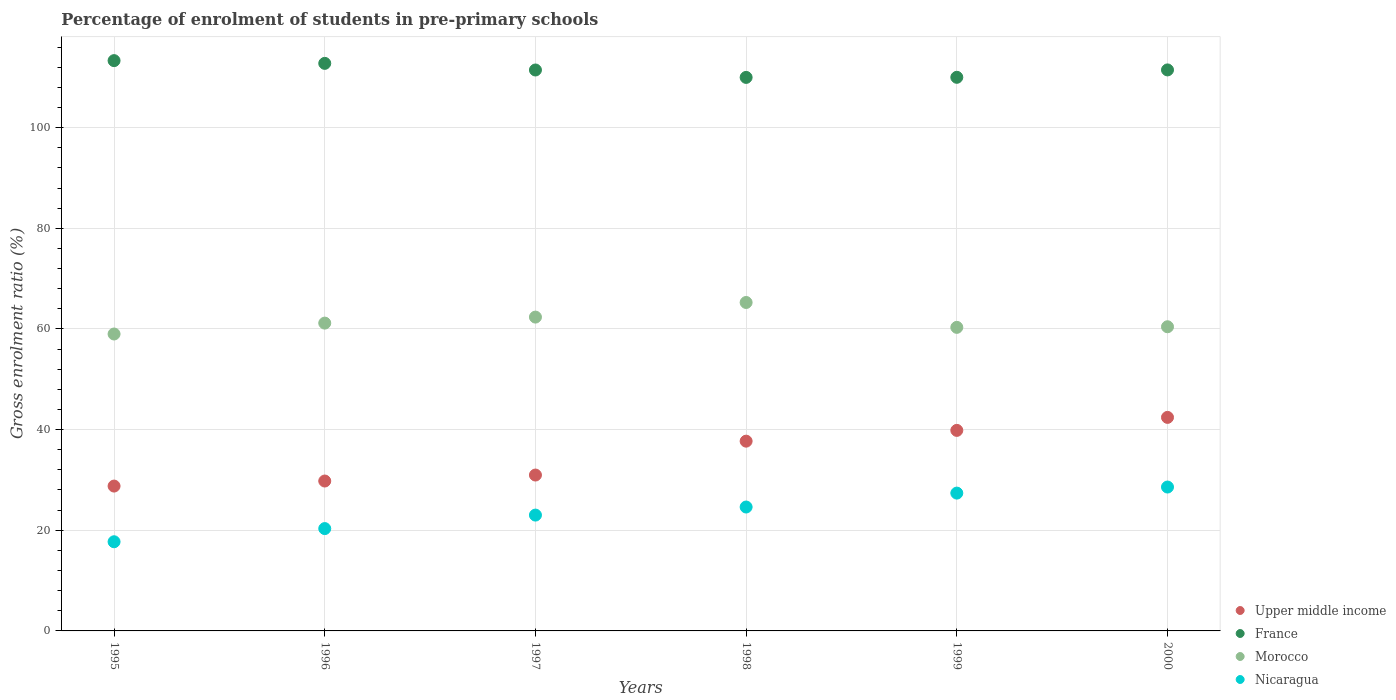Is the number of dotlines equal to the number of legend labels?
Provide a succinct answer. Yes. What is the percentage of students enrolled in pre-primary schools in Nicaragua in 1999?
Offer a terse response. 27.38. Across all years, what is the maximum percentage of students enrolled in pre-primary schools in Upper middle income?
Your answer should be very brief. 42.43. Across all years, what is the minimum percentage of students enrolled in pre-primary schools in France?
Offer a terse response. 109.98. In which year was the percentage of students enrolled in pre-primary schools in Upper middle income maximum?
Provide a succinct answer. 2000. In which year was the percentage of students enrolled in pre-primary schools in Nicaragua minimum?
Offer a terse response. 1995. What is the total percentage of students enrolled in pre-primary schools in Nicaragua in the graph?
Offer a very short reply. 141.65. What is the difference between the percentage of students enrolled in pre-primary schools in Morocco in 1997 and that in 1999?
Ensure brevity in your answer.  2.04. What is the difference between the percentage of students enrolled in pre-primary schools in Nicaragua in 1995 and the percentage of students enrolled in pre-primary schools in Upper middle income in 2000?
Your answer should be very brief. -24.71. What is the average percentage of students enrolled in pre-primary schools in Nicaragua per year?
Give a very brief answer. 23.61. In the year 1999, what is the difference between the percentage of students enrolled in pre-primary schools in Upper middle income and percentage of students enrolled in pre-primary schools in France?
Provide a short and direct response. -70.15. What is the ratio of the percentage of students enrolled in pre-primary schools in Nicaragua in 1998 to that in 2000?
Provide a succinct answer. 0.86. Is the difference between the percentage of students enrolled in pre-primary schools in Upper middle income in 1999 and 2000 greater than the difference between the percentage of students enrolled in pre-primary schools in France in 1999 and 2000?
Provide a succinct answer. No. What is the difference between the highest and the second highest percentage of students enrolled in pre-primary schools in Morocco?
Offer a terse response. 2.9. What is the difference between the highest and the lowest percentage of students enrolled in pre-primary schools in Upper middle income?
Provide a short and direct response. 13.65. Is it the case that in every year, the sum of the percentage of students enrolled in pre-primary schools in France and percentage of students enrolled in pre-primary schools in Nicaragua  is greater than the percentage of students enrolled in pre-primary schools in Morocco?
Make the answer very short. Yes. Does the percentage of students enrolled in pre-primary schools in France monotonically increase over the years?
Provide a succinct answer. No. How many years are there in the graph?
Your answer should be very brief. 6. Are the values on the major ticks of Y-axis written in scientific E-notation?
Provide a short and direct response. No. What is the title of the graph?
Your answer should be very brief. Percentage of enrolment of students in pre-primary schools. What is the label or title of the X-axis?
Provide a succinct answer. Years. What is the Gross enrolment ratio (%) in Upper middle income in 1995?
Provide a succinct answer. 28.78. What is the Gross enrolment ratio (%) of France in 1995?
Make the answer very short. 113.31. What is the Gross enrolment ratio (%) of Morocco in 1995?
Give a very brief answer. 58.99. What is the Gross enrolment ratio (%) in Nicaragua in 1995?
Ensure brevity in your answer.  17.72. What is the Gross enrolment ratio (%) in Upper middle income in 1996?
Keep it short and to the point. 29.78. What is the Gross enrolment ratio (%) of France in 1996?
Your response must be concise. 112.77. What is the Gross enrolment ratio (%) in Morocco in 1996?
Your response must be concise. 61.16. What is the Gross enrolment ratio (%) in Nicaragua in 1996?
Ensure brevity in your answer.  20.33. What is the Gross enrolment ratio (%) of Upper middle income in 1997?
Keep it short and to the point. 30.97. What is the Gross enrolment ratio (%) of France in 1997?
Offer a very short reply. 111.45. What is the Gross enrolment ratio (%) in Morocco in 1997?
Keep it short and to the point. 62.35. What is the Gross enrolment ratio (%) in Nicaragua in 1997?
Your answer should be very brief. 23.01. What is the Gross enrolment ratio (%) in Upper middle income in 1998?
Keep it short and to the point. 37.7. What is the Gross enrolment ratio (%) in France in 1998?
Your answer should be very brief. 109.98. What is the Gross enrolment ratio (%) of Morocco in 1998?
Provide a short and direct response. 65.26. What is the Gross enrolment ratio (%) of Nicaragua in 1998?
Make the answer very short. 24.62. What is the Gross enrolment ratio (%) in Upper middle income in 1999?
Offer a very short reply. 39.85. What is the Gross enrolment ratio (%) of France in 1999?
Provide a succinct answer. 110. What is the Gross enrolment ratio (%) in Morocco in 1999?
Offer a very short reply. 60.31. What is the Gross enrolment ratio (%) of Nicaragua in 1999?
Keep it short and to the point. 27.38. What is the Gross enrolment ratio (%) of Upper middle income in 2000?
Keep it short and to the point. 42.43. What is the Gross enrolment ratio (%) of France in 2000?
Your answer should be compact. 111.47. What is the Gross enrolment ratio (%) of Morocco in 2000?
Keep it short and to the point. 60.43. What is the Gross enrolment ratio (%) of Nicaragua in 2000?
Offer a very short reply. 28.59. Across all years, what is the maximum Gross enrolment ratio (%) in Upper middle income?
Your response must be concise. 42.43. Across all years, what is the maximum Gross enrolment ratio (%) of France?
Your answer should be very brief. 113.31. Across all years, what is the maximum Gross enrolment ratio (%) of Morocco?
Your answer should be very brief. 65.26. Across all years, what is the maximum Gross enrolment ratio (%) in Nicaragua?
Your response must be concise. 28.59. Across all years, what is the minimum Gross enrolment ratio (%) of Upper middle income?
Provide a succinct answer. 28.78. Across all years, what is the minimum Gross enrolment ratio (%) of France?
Your response must be concise. 109.98. Across all years, what is the minimum Gross enrolment ratio (%) in Morocco?
Keep it short and to the point. 58.99. Across all years, what is the minimum Gross enrolment ratio (%) of Nicaragua?
Your answer should be compact. 17.72. What is the total Gross enrolment ratio (%) of Upper middle income in the graph?
Offer a terse response. 209.51. What is the total Gross enrolment ratio (%) in France in the graph?
Provide a succinct answer. 668.97. What is the total Gross enrolment ratio (%) of Morocco in the graph?
Make the answer very short. 368.51. What is the total Gross enrolment ratio (%) of Nicaragua in the graph?
Make the answer very short. 141.65. What is the difference between the Gross enrolment ratio (%) in Upper middle income in 1995 and that in 1996?
Offer a very short reply. -1. What is the difference between the Gross enrolment ratio (%) in France in 1995 and that in 1996?
Your response must be concise. 0.54. What is the difference between the Gross enrolment ratio (%) in Morocco in 1995 and that in 1996?
Give a very brief answer. -2.16. What is the difference between the Gross enrolment ratio (%) in Nicaragua in 1995 and that in 1996?
Your answer should be compact. -2.62. What is the difference between the Gross enrolment ratio (%) in Upper middle income in 1995 and that in 1997?
Keep it short and to the point. -2.19. What is the difference between the Gross enrolment ratio (%) of France in 1995 and that in 1997?
Your answer should be very brief. 1.86. What is the difference between the Gross enrolment ratio (%) of Morocco in 1995 and that in 1997?
Make the answer very short. -3.36. What is the difference between the Gross enrolment ratio (%) of Nicaragua in 1995 and that in 1997?
Your answer should be very brief. -5.3. What is the difference between the Gross enrolment ratio (%) of Upper middle income in 1995 and that in 1998?
Your answer should be compact. -8.92. What is the difference between the Gross enrolment ratio (%) in France in 1995 and that in 1998?
Ensure brevity in your answer.  3.33. What is the difference between the Gross enrolment ratio (%) in Morocco in 1995 and that in 1998?
Offer a very short reply. -6.26. What is the difference between the Gross enrolment ratio (%) of Nicaragua in 1995 and that in 1998?
Provide a succinct answer. -6.9. What is the difference between the Gross enrolment ratio (%) in Upper middle income in 1995 and that in 1999?
Your answer should be very brief. -11.06. What is the difference between the Gross enrolment ratio (%) in France in 1995 and that in 1999?
Give a very brief answer. 3.31. What is the difference between the Gross enrolment ratio (%) in Morocco in 1995 and that in 1999?
Provide a short and direct response. -1.32. What is the difference between the Gross enrolment ratio (%) in Nicaragua in 1995 and that in 1999?
Make the answer very short. -9.67. What is the difference between the Gross enrolment ratio (%) in Upper middle income in 1995 and that in 2000?
Offer a terse response. -13.65. What is the difference between the Gross enrolment ratio (%) in France in 1995 and that in 2000?
Offer a very short reply. 1.84. What is the difference between the Gross enrolment ratio (%) in Morocco in 1995 and that in 2000?
Your response must be concise. -1.44. What is the difference between the Gross enrolment ratio (%) in Nicaragua in 1995 and that in 2000?
Offer a terse response. -10.87. What is the difference between the Gross enrolment ratio (%) in Upper middle income in 1996 and that in 1997?
Give a very brief answer. -1.19. What is the difference between the Gross enrolment ratio (%) of France in 1996 and that in 1997?
Your answer should be compact. 1.32. What is the difference between the Gross enrolment ratio (%) in Morocco in 1996 and that in 1997?
Offer a very short reply. -1.19. What is the difference between the Gross enrolment ratio (%) in Nicaragua in 1996 and that in 1997?
Make the answer very short. -2.68. What is the difference between the Gross enrolment ratio (%) of Upper middle income in 1996 and that in 1998?
Your answer should be very brief. -7.92. What is the difference between the Gross enrolment ratio (%) of France in 1996 and that in 1998?
Your answer should be compact. 2.79. What is the difference between the Gross enrolment ratio (%) of Morocco in 1996 and that in 1998?
Offer a terse response. -4.1. What is the difference between the Gross enrolment ratio (%) of Nicaragua in 1996 and that in 1998?
Your response must be concise. -4.28. What is the difference between the Gross enrolment ratio (%) of Upper middle income in 1996 and that in 1999?
Your answer should be very brief. -10.06. What is the difference between the Gross enrolment ratio (%) of France in 1996 and that in 1999?
Provide a short and direct response. 2.77. What is the difference between the Gross enrolment ratio (%) in Morocco in 1996 and that in 1999?
Ensure brevity in your answer.  0.84. What is the difference between the Gross enrolment ratio (%) of Nicaragua in 1996 and that in 1999?
Make the answer very short. -7.05. What is the difference between the Gross enrolment ratio (%) in Upper middle income in 1996 and that in 2000?
Offer a very short reply. -12.64. What is the difference between the Gross enrolment ratio (%) of France in 1996 and that in 2000?
Offer a very short reply. 1.3. What is the difference between the Gross enrolment ratio (%) of Morocco in 1996 and that in 2000?
Offer a very short reply. 0.73. What is the difference between the Gross enrolment ratio (%) of Nicaragua in 1996 and that in 2000?
Your answer should be very brief. -8.25. What is the difference between the Gross enrolment ratio (%) in Upper middle income in 1997 and that in 1998?
Your answer should be compact. -6.73. What is the difference between the Gross enrolment ratio (%) of France in 1997 and that in 1998?
Your response must be concise. 1.47. What is the difference between the Gross enrolment ratio (%) of Morocco in 1997 and that in 1998?
Offer a very short reply. -2.9. What is the difference between the Gross enrolment ratio (%) of Nicaragua in 1997 and that in 1998?
Your response must be concise. -1.6. What is the difference between the Gross enrolment ratio (%) in Upper middle income in 1997 and that in 1999?
Keep it short and to the point. -8.87. What is the difference between the Gross enrolment ratio (%) of France in 1997 and that in 1999?
Your answer should be compact. 1.45. What is the difference between the Gross enrolment ratio (%) of Morocco in 1997 and that in 1999?
Your answer should be compact. 2.04. What is the difference between the Gross enrolment ratio (%) in Nicaragua in 1997 and that in 1999?
Provide a succinct answer. -4.37. What is the difference between the Gross enrolment ratio (%) in Upper middle income in 1997 and that in 2000?
Make the answer very short. -11.46. What is the difference between the Gross enrolment ratio (%) of France in 1997 and that in 2000?
Make the answer very short. -0.02. What is the difference between the Gross enrolment ratio (%) in Morocco in 1997 and that in 2000?
Ensure brevity in your answer.  1.92. What is the difference between the Gross enrolment ratio (%) in Nicaragua in 1997 and that in 2000?
Offer a terse response. -5.57. What is the difference between the Gross enrolment ratio (%) in Upper middle income in 1998 and that in 1999?
Offer a very short reply. -2.14. What is the difference between the Gross enrolment ratio (%) of France in 1998 and that in 1999?
Ensure brevity in your answer.  -0.02. What is the difference between the Gross enrolment ratio (%) of Morocco in 1998 and that in 1999?
Ensure brevity in your answer.  4.94. What is the difference between the Gross enrolment ratio (%) of Nicaragua in 1998 and that in 1999?
Provide a short and direct response. -2.77. What is the difference between the Gross enrolment ratio (%) in Upper middle income in 1998 and that in 2000?
Your answer should be compact. -4.72. What is the difference between the Gross enrolment ratio (%) of France in 1998 and that in 2000?
Give a very brief answer. -1.49. What is the difference between the Gross enrolment ratio (%) in Morocco in 1998 and that in 2000?
Offer a very short reply. 4.82. What is the difference between the Gross enrolment ratio (%) of Nicaragua in 1998 and that in 2000?
Your answer should be compact. -3.97. What is the difference between the Gross enrolment ratio (%) in Upper middle income in 1999 and that in 2000?
Offer a very short reply. -2.58. What is the difference between the Gross enrolment ratio (%) in France in 1999 and that in 2000?
Provide a succinct answer. -1.47. What is the difference between the Gross enrolment ratio (%) in Morocco in 1999 and that in 2000?
Your answer should be compact. -0.12. What is the difference between the Gross enrolment ratio (%) of Nicaragua in 1999 and that in 2000?
Your response must be concise. -1.2. What is the difference between the Gross enrolment ratio (%) in Upper middle income in 1995 and the Gross enrolment ratio (%) in France in 1996?
Your answer should be compact. -83.99. What is the difference between the Gross enrolment ratio (%) in Upper middle income in 1995 and the Gross enrolment ratio (%) in Morocco in 1996?
Offer a terse response. -32.38. What is the difference between the Gross enrolment ratio (%) of Upper middle income in 1995 and the Gross enrolment ratio (%) of Nicaragua in 1996?
Your answer should be very brief. 8.45. What is the difference between the Gross enrolment ratio (%) of France in 1995 and the Gross enrolment ratio (%) of Morocco in 1996?
Give a very brief answer. 52.15. What is the difference between the Gross enrolment ratio (%) of France in 1995 and the Gross enrolment ratio (%) of Nicaragua in 1996?
Your answer should be very brief. 92.98. What is the difference between the Gross enrolment ratio (%) of Morocco in 1995 and the Gross enrolment ratio (%) of Nicaragua in 1996?
Your answer should be very brief. 38.66. What is the difference between the Gross enrolment ratio (%) of Upper middle income in 1995 and the Gross enrolment ratio (%) of France in 1997?
Make the answer very short. -82.67. What is the difference between the Gross enrolment ratio (%) in Upper middle income in 1995 and the Gross enrolment ratio (%) in Morocco in 1997?
Offer a terse response. -33.57. What is the difference between the Gross enrolment ratio (%) of Upper middle income in 1995 and the Gross enrolment ratio (%) of Nicaragua in 1997?
Your answer should be compact. 5.77. What is the difference between the Gross enrolment ratio (%) in France in 1995 and the Gross enrolment ratio (%) in Morocco in 1997?
Offer a terse response. 50.96. What is the difference between the Gross enrolment ratio (%) of France in 1995 and the Gross enrolment ratio (%) of Nicaragua in 1997?
Your answer should be compact. 90.3. What is the difference between the Gross enrolment ratio (%) in Morocco in 1995 and the Gross enrolment ratio (%) in Nicaragua in 1997?
Make the answer very short. 35.98. What is the difference between the Gross enrolment ratio (%) of Upper middle income in 1995 and the Gross enrolment ratio (%) of France in 1998?
Your answer should be compact. -81.2. What is the difference between the Gross enrolment ratio (%) in Upper middle income in 1995 and the Gross enrolment ratio (%) in Morocco in 1998?
Keep it short and to the point. -36.48. What is the difference between the Gross enrolment ratio (%) in Upper middle income in 1995 and the Gross enrolment ratio (%) in Nicaragua in 1998?
Ensure brevity in your answer.  4.16. What is the difference between the Gross enrolment ratio (%) of France in 1995 and the Gross enrolment ratio (%) of Morocco in 1998?
Give a very brief answer. 48.05. What is the difference between the Gross enrolment ratio (%) in France in 1995 and the Gross enrolment ratio (%) in Nicaragua in 1998?
Your answer should be very brief. 88.69. What is the difference between the Gross enrolment ratio (%) in Morocco in 1995 and the Gross enrolment ratio (%) in Nicaragua in 1998?
Provide a short and direct response. 34.38. What is the difference between the Gross enrolment ratio (%) of Upper middle income in 1995 and the Gross enrolment ratio (%) of France in 1999?
Keep it short and to the point. -81.22. What is the difference between the Gross enrolment ratio (%) in Upper middle income in 1995 and the Gross enrolment ratio (%) in Morocco in 1999?
Give a very brief answer. -31.53. What is the difference between the Gross enrolment ratio (%) of Upper middle income in 1995 and the Gross enrolment ratio (%) of Nicaragua in 1999?
Your answer should be very brief. 1.4. What is the difference between the Gross enrolment ratio (%) in France in 1995 and the Gross enrolment ratio (%) in Morocco in 1999?
Provide a succinct answer. 53. What is the difference between the Gross enrolment ratio (%) of France in 1995 and the Gross enrolment ratio (%) of Nicaragua in 1999?
Your answer should be very brief. 85.93. What is the difference between the Gross enrolment ratio (%) in Morocco in 1995 and the Gross enrolment ratio (%) in Nicaragua in 1999?
Your answer should be compact. 31.61. What is the difference between the Gross enrolment ratio (%) in Upper middle income in 1995 and the Gross enrolment ratio (%) in France in 2000?
Ensure brevity in your answer.  -82.69. What is the difference between the Gross enrolment ratio (%) of Upper middle income in 1995 and the Gross enrolment ratio (%) of Morocco in 2000?
Your answer should be compact. -31.65. What is the difference between the Gross enrolment ratio (%) of Upper middle income in 1995 and the Gross enrolment ratio (%) of Nicaragua in 2000?
Offer a very short reply. 0.19. What is the difference between the Gross enrolment ratio (%) in France in 1995 and the Gross enrolment ratio (%) in Morocco in 2000?
Provide a succinct answer. 52.88. What is the difference between the Gross enrolment ratio (%) in France in 1995 and the Gross enrolment ratio (%) in Nicaragua in 2000?
Ensure brevity in your answer.  84.72. What is the difference between the Gross enrolment ratio (%) in Morocco in 1995 and the Gross enrolment ratio (%) in Nicaragua in 2000?
Your answer should be compact. 30.41. What is the difference between the Gross enrolment ratio (%) in Upper middle income in 1996 and the Gross enrolment ratio (%) in France in 1997?
Your answer should be compact. -81.67. What is the difference between the Gross enrolment ratio (%) of Upper middle income in 1996 and the Gross enrolment ratio (%) of Morocco in 1997?
Keep it short and to the point. -32.57. What is the difference between the Gross enrolment ratio (%) in Upper middle income in 1996 and the Gross enrolment ratio (%) in Nicaragua in 1997?
Keep it short and to the point. 6.77. What is the difference between the Gross enrolment ratio (%) of France in 1996 and the Gross enrolment ratio (%) of Morocco in 1997?
Offer a very short reply. 50.41. What is the difference between the Gross enrolment ratio (%) in France in 1996 and the Gross enrolment ratio (%) in Nicaragua in 1997?
Keep it short and to the point. 89.75. What is the difference between the Gross enrolment ratio (%) of Morocco in 1996 and the Gross enrolment ratio (%) of Nicaragua in 1997?
Offer a terse response. 38.14. What is the difference between the Gross enrolment ratio (%) of Upper middle income in 1996 and the Gross enrolment ratio (%) of France in 1998?
Ensure brevity in your answer.  -80.19. What is the difference between the Gross enrolment ratio (%) in Upper middle income in 1996 and the Gross enrolment ratio (%) in Morocco in 1998?
Your answer should be compact. -35.47. What is the difference between the Gross enrolment ratio (%) in Upper middle income in 1996 and the Gross enrolment ratio (%) in Nicaragua in 1998?
Provide a short and direct response. 5.17. What is the difference between the Gross enrolment ratio (%) of France in 1996 and the Gross enrolment ratio (%) of Morocco in 1998?
Give a very brief answer. 47.51. What is the difference between the Gross enrolment ratio (%) in France in 1996 and the Gross enrolment ratio (%) in Nicaragua in 1998?
Your response must be concise. 88.15. What is the difference between the Gross enrolment ratio (%) of Morocco in 1996 and the Gross enrolment ratio (%) of Nicaragua in 1998?
Your response must be concise. 36.54. What is the difference between the Gross enrolment ratio (%) of Upper middle income in 1996 and the Gross enrolment ratio (%) of France in 1999?
Your response must be concise. -80.21. What is the difference between the Gross enrolment ratio (%) of Upper middle income in 1996 and the Gross enrolment ratio (%) of Morocco in 1999?
Offer a terse response. -30.53. What is the difference between the Gross enrolment ratio (%) in Upper middle income in 1996 and the Gross enrolment ratio (%) in Nicaragua in 1999?
Your answer should be very brief. 2.4. What is the difference between the Gross enrolment ratio (%) in France in 1996 and the Gross enrolment ratio (%) in Morocco in 1999?
Your response must be concise. 52.45. What is the difference between the Gross enrolment ratio (%) in France in 1996 and the Gross enrolment ratio (%) in Nicaragua in 1999?
Your response must be concise. 85.38. What is the difference between the Gross enrolment ratio (%) in Morocco in 1996 and the Gross enrolment ratio (%) in Nicaragua in 1999?
Offer a terse response. 33.78. What is the difference between the Gross enrolment ratio (%) in Upper middle income in 1996 and the Gross enrolment ratio (%) in France in 2000?
Offer a terse response. -81.68. What is the difference between the Gross enrolment ratio (%) in Upper middle income in 1996 and the Gross enrolment ratio (%) in Morocco in 2000?
Your answer should be very brief. -30.65. What is the difference between the Gross enrolment ratio (%) in Upper middle income in 1996 and the Gross enrolment ratio (%) in Nicaragua in 2000?
Your answer should be compact. 1.2. What is the difference between the Gross enrolment ratio (%) in France in 1996 and the Gross enrolment ratio (%) in Morocco in 2000?
Your answer should be compact. 52.33. What is the difference between the Gross enrolment ratio (%) in France in 1996 and the Gross enrolment ratio (%) in Nicaragua in 2000?
Your answer should be very brief. 84.18. What is the difference between the Gross enrolment ratio (%) in Morocco in 1996 and the Gross enrolment ratio (%) in Nicaragua in 2000?
Make the answer very short. 32.57. What is the difference between the Gross enrolment ratio (%) in Upper middle income in 1997 and the Gross enrolment ratio (%) in France in 1998?
Give a very brief answer. -79.01. What is the difference between the Gross enrolment ratio (%) in Upper middle income in 1997 and the Gross enrolment ratio (%) in Morocco in 1998?
Offer a very short reply. -34.29. What is the difference between the Gross enrolment ratio (%) in Upper middle income in 1997 and the Gross enrolment ratio (%) in Nicaragua in 1998?
Your answer should be compact. 6.35. What is the difference between the Gross enrolment ratio (%) in France in 1997 and the Gross enrolment ratio (%) in Morocco in 1998?
Provide a succinct answer. 46.19. What is the difference between the Gross enrolment ratio (%) of France in 1997 and the Gross enrolment ratio (%) of Nicaragua in 1998?
Keep it short and to the point. 86.83. What is the difference between the Gross enrolment ratio (%) in Morocco in 1997 and the Gross enrolment ratio (%) in Nicaragua in 1998?
Offer a terse response. 37.74. What is the difference between the Gross enrolment ratio (%) in Upper middle income in 1997 and the Gross enrolment ratio (%) in France in 1999?
Keep it short and to the point. -79.03. What is the difference between the Gross enrolment ratio (%) in Upper middle income in 1997 and the Gross enrolment ratio (%) in Morocco in 1999?
Make the answer very short. -29.34. What is the difference between the Gross enrolment ratio (%) of Upper middle income in 1997 and the Gross enrolment ratio (%) of Nicaragua in 1999?
Offer a terse response. 3.59. What is the difference between the Gross enrolment ratio (%) of France in 1997 and the Gross enrolment ratio (%) of Morocco in 1999?
Keep it short and to the point. 51.14. What is the difference between the Gross enrolment ratio (%) of France in 1997 and the Gross enrolment ratio (%) of Nicaragua in 1999?
Provide a succinct answer. 84.07. What is the difference between the Gross enrolment ratio (%) in Morocco in 1997 and the Gross enrolment ratio (%) in Nicaragua in 1999?
Offer a terse response. 34.97. What is the difference between the Gross enrolment ratio (%) in Upper middle income in 1997 and the Gross enrolment ratio (%) in France in 2000?
Give a very brief answer. -80.49. What is the difference between the Gross enrolment ratio (%) of Upper middle income in 1997 and the Gross enrolment ratio (%) of Morocco in 2000?
Offer a terse response. -29.46. What is the difference between the Gross enrolment ratio (%) of Upper middle income in 1997 and the Gross enrolment ratio (%) of Nicaragua in 2000?
Your answer should be compact. 2.38. What is the difference between the Gross enrolment ratio (%) of France in 1997 and the Gross enrolment ratio (%) of Morocco in 2000?
Provide a succinct answer. 51.02. What is the difference between the Gross enrolment ratio (%) of France in 1997 and the Gross enrolment ratio (%) of Nicaragua in 2000?
Your answer should be very brief. 82.86. What is the difference between the Gross enrolment ratio (%) of Morocco in 1997 and the Gross enrolment ratio (%) of Nicaragua in 2000?
Your response must be concise. 33.77. What is the difference between the Gross enrolment ratio (%) in Upper middle income in 1998 and the Gross enrolment ratio (%) in France in 1999?
Make the answer very short. -72.29. What is the difference between the Gross enrolment ratio (%) of Upper middle income in 1998 and the Gross enrolment ratio (%) of Morocco in 1999?
Your response must be concise. -22.61. What is the difference between the Gross enrolment ratio (%) of Upper middle income in 1998 and the Gross enrolment ratio (%) of Nicaragua in 1999?
Provide a succinct answer. 10.32. What is the difference between the Gross enrolment ratio (%) of France in 1998 and the Gross enrolment ratio (%) of Morocco in 1999?
Keep it short and to the point. 49.66. What is the difference between the Gross enrolment ratio (%) in France in 1998 and the Gross enrolment ratio (%) in Nicaragua in 1999?
Offer a very short reply. 82.6. What is the difference between the Gross enrolment ratio (%) of Morocco in 1998 and the Gross enrolment ratio (%) of Nicaragua in 1999?
Keep it short and to the point. 37.87. What is the difference between the Gross enrolment ratio (%) in Upper middle income in 1998 and the Gross enrolment ratio (%) in France in 2000?
Ensure brevity in your answer.  -73.76. What is the difference between the Gross enrolment ratio (%) in Upper middle income in 1998 and the Gross enrolment ratio (%) in Morocco in 2000?
Give a very brief answer. -22.73. What is the difference between the Gross enrolment ratio (%) in Upper middle income in 1998 and the Gross enrolment ratio (%) in Nicaragua in 2000?
Provide a short and direct response. 9.12. What is the difference between the Gross enrolment ratio (%) in France in 1998 and the Gross enrolment ratio (%) in Morocco in 2000?
Give a very brief answer. 49.54. What is the difference between the Gross enrolment ratio (%) in France in 1998 and the Gross enrolment ratio (%) in Nicaragua in 2000?
Keep it short and to the point. 81.39. What is the difference between the Gross enrolment ratio (%) in Morocco in 1998 and the Gross enrolment ratio (%) in Nicaragua in 2000?
Offer a terse response. 36.67. What is the difference between the Gross enrolment ratio (%) in Upper middle income in 1999 and the Gross enrolment ratio (%) in France in 2000?
Give a very brief answer. -71.62. What is the difference between the Gross enrolment ratio (%) of Upper middle income in 1999 and the Gross enrolment ratio (%) of Morocco in 2000?
Your answer should be very brief. -20.59. What is the difference between the Gross enrolment ratio (%) in Upper middle income in 1999 and the Gross enrolment ratio (%) in Nicaragua in 2000?
Keep it short and to the point. 11.26. What is the difference between the Gross enrolment ratio (%) of France in 1999 and the Gross enrolment ratio (%) of Morocco in 2000?
Provide a short and direct response. 49.56. What is the difference between the Gross enrolment ratio (%) in France in 1999 and the Gross enrolment ratio (%) in Nicaragua in 2000?
Offer a terse response. 81.41. What is the difference between the Gross enrolment ratio (%) in Morocco in 1999 and the Gross enrolment ratio (%) in Nicaragua in 2000?
Ensure brevity in your answer.  31.73. What is the average Gross enrolment ratio (%) of Upper middle income per year?
Offer a very short reply. 34.92. What is the average Gross enrolment ratio (%) of France per year?
Make the answer very short. 111.49. What is the average Gross enrolment ratio (%) of Morocco per year?
Provide a succinct answer. 61.42. What is the average Gross enrolment ratio (%) of Nicaragua per year?
Provide a short and direct response. 23.61. In the year 1995, what is the difference between the Gross enrolment ratio (%) of Upper middle income and Gross enrolment ratio (%) of France?
Your answer should be very brief. -84.53. In the year 1995, what is the difference between the Gross enrolment ratio (%) of Upper middle income and Gross enrolment ratio (%) of Morocco?
Your answer should be compact. -30.21. In the year 1995, what is the difference between the Gross enrolment ratio (%) in Upper middle income and Gross enrolment ratio (%) in Nicaragua?
Provide a short and direct response. 11.06. In the year 1995, what is the difference between the Gross enrolment ratio (%) in France and Gross enrolment ratio (%) in Morocco?
Your response must be concise. 54.32. In the year 1995, what is the difference between the Gross enrolment ratio (%) in France and Gross enrolment ratio (%) in Nicaragua?
Your answer should be compact. 95.59. In the year 1995, what is the difference between the Gross enrolment ratio (%) in Morocco and Gross enrolment ratio (%) in Nicaragua?
Keep it short and to the point. 41.28. In the year 1996, what is the difference between the Gross enrolment ratio (%) of Upper middle income and Gross enrolment ratio (%) of France?
Your response must be concise. -82.98. In the year 1996, what is the difference between the Gross enrolment ratio (%) in Upper middle income and Gross enrolment ratio (%) in Morocco?
Offer a terse response. -31.38. In the year 1996, what is the difference between the Gross enrolment ratio (%) in Upper middle income and Gross enrolment ratio (%) in Nicaragua?
Your response must be concise. 9.45. In the year 1996, what is the difference between the Gross enrolment ratio (%) in France and Gross enrolment ratio (%) in Morocco?
Offer a terse response. 51.61. In the year 1996, what is the difference between the Gross enrolment ratio (%) of France and Gross enrolment ratio (%) of Nicaragua?
Offer a very short reply. 92.43. In the year 1996, what is the difference between the Gross enrolment ratio (%) of Morocco and Gross enrolment ratio (%) of Nicaragua?
Your response must be concise. 40.83. In the year 1997, what is the difference between the Gross enrolment ratio (%) of Upper middle income and Gross enrolment ratio (%) of France?
Make the answer very short. -80.48. In the year 1997, what is the difference between the Gross enrolment ratio (%) of Upper middle income and Gross enrolment ratio (%) of Morocco?
Offer a terse response. -31.38. In the year 1997, what is the difference between the Gross enrolment ratio (%) of Upper middle income and Gross enrolment ratio (%) of Nicaragua?
Provide a succinct answer. 7.96. In the year 1997, what is the difference between the Gross enrolment ratio (%) of France and Gross enrolment ratio (%) of Morocco?
Offer a very short reply. 49.1. In the year 1997, what is the difference between the Gross enrolment ratio (%) in France and Gross enrolment ratio (%) in Nicaragua?
Offer a very short reply. 88.44. In the year 1997, what is the difference between the Gross enrolment ratio (%) in Morocco and Gross enrolment ratio (%) in Nicaragua?
Make the answer very short. 39.34. In the year 1998, what is the difference between the Gross enrolment ratio (%) of Upper middle income and Gross enrolment ratio (%) of France?
Offer a terse response. -72.27. In the year 1998, what is the difference between the Gross enrolment ratio (%) of Upper middle income and Gross enrolment ratio (%) of Morocco?
Give a very brief answer. -27.55. In the year 1998, what is the difference between the Gross enrolment ratio (%) in Upper middle income and Gross enrolment ratio (%) in Nicaragua?
Offer a very short reply. 13.09. In the year 1998, what is the difference between the Gross enrolment ratio (%) in France and Gross enrolment ratio (%) in Morocco?
Ensure brevity in your answer.  44.72. In the year 1998, what is the difference between the Gross enrolment ratio (%) of France and Gross enrolment ratio (%) of Nicaragua?
Offer a terse response. 85.36. In the year 1998, what is the difference between the Gross enrolment ratio (%) of Morocco and Gross enrolment ratio (%) of Nicaragua?
Give a very brief answer. 40.64. In the year 1999, what is the difference between the Gross enrolment ratio (%) of Upper middle income and Gross enrolment ratio (%) of France?
Your answer should be very brief. -70.15. In the year 1999, what is the difference between the Gross enrolment ratio (%) of Upper middle income and Gross enrolment ratio (%) of Morocco?
Ensure brevity in your answer.  -20.47. In the year 1999, what is the difference between the Gross enrolment ratio (%) of Upper middle income and Gross enrolment ratio (%) of Nicaragua?
Your response must be concise. 12.46. In the year 1999, what is the difference between the Gross enrolment ratio (%) in France and Gross enrolment ratio (%) in Morocco?
Make the answer very short. 49.68. In the year 1999, what is the difference between the Gross enrolment ratio (%) in France and Gross enrolment ratio (%) in Nicaragua?
Ensure brevity in your answer.  82.61. In the year 1999, what is the difference between the Gross enrolment ratio (%) of Morocco and Gross enrolment ratio (%) of Nicaragua?
Offer a terse response. 32.93. In the year 2000, what is the difference between the Gross enrolment ratio (%) of Upper middle income and Gross enrolment ratio (%) of France?
Make the answer very short. -69.04. In the year 2000, what is the difference between the Gross enrolment ratio (%) of Upper middle income and Gross enrolment ratio (%) of Morocco?
Your answer should be compact. -18.01. In the year 2000, what is the difference between the Gross enrolment ratio (%) of Upper middle income and Gross enrolment ratio (%) of Nicaragua?
Provide a short and direct response. 13.84. In the year 2000, what is the difference between the Gross enrolment ratio (%) of France and Gross enrolment ratio (%) of Morocco?
Provide a succinct answer. 51.03. In the year 2000, what is the difference between the Gross enrolment ratio (%) of France and Gross enrolment ratio (%) of Nicaragua?
Offer a very short reply. 82.88. In the year 2000, what is the difference between the Gross enrolment ratio (%) of Morocco and Gross enrolment ratio (%) of Nicaragua?
Make the answer very short. 31.85. What is the ratio of the Gross enrolment ratio (%) in Upper middle income in 1995 to that in 1996?
Offer a very short reply. 0.97. What is the ratio of the Gross enrolment ratio (%) of Morocco in 1995 to that in 1996?
Your response must be concise. 0.96. What is the ratio of the Gross enrolment ratio (%) in Nicaragua in 1995 to that in 1996?
Your answer should be compact. 0.87. What is the ratio of the Gross enrolment ratio (%) in Upper middle income in 1995 to that in 1997?
Offer a very short reply. 0.93. What is the ratio of the Gross enrolment ratio (%) in France in 1995 to that in 1997?
Your response must be concise. 1.02. What is the ratio of the Gross enrolment ratio (%) in Morocco in 1995 to that in 1997?
Provide a short and direct response. 0.95. What is the ratio of the Gross enrolment ratio (%) of Nicaragua in 1995 to that in 1997?
Provide a short and direct response. 0.77. What is the ratio of the Gross enrolment ratio (%) in Upper middle income in 1995 to that in 1998?
Provide a short and direct response. 0.76. What is the ratio of the Gross enrolment ratio (%) of France in 1995 to that in 1998?
Provide a succinct answer. 1.03. What is the ratio of the Gross enrolment ratio (%) of Morocco in 1995 to that in 1998?
Give a very brief answer. 0.9. What is the ratio of the Gross enrolment ratio (%) of Nicaragua in 1995 to that in 1998?
Give a very brief answer. 0.72. What is the ratio of the Gross enrolment ratio (%) of Upper middle income in 1995 to that in 1999?
Give a very brief answer. 0.72. What is the ratio of the Gross enrolment ratio (%) of France in 1995 to that in 1999?
Your answer should be very brief. 1.03. What is the ratio of the Gross enrolment ratio (%) of Morocco in 1995 to that in 1999?
Your answer should be compact. 0.98. What is the ratio of the Gross enrolment ratio (%) of Nicaragua in 1995 to that in 1999?
Provide a succinct answer. 0.65. What is the ratio of the Gross enrolment ratio (%) in Upper middle income in 1995 to that in 2000?
Ensure brevity in your answer.  0.68. What is the ratio of the Gross enrolment ratio (%) in France in 1995 to that in 2000?
Offer a terse response. 1.02. What is the ratio of the Gross enrolment ratio (%) of Morocco in 1995 to that in 2000?
Give a very brief answer. 0.98. What is the ratio of the Gross enrolment ratio (%) of Nicaragua in 1995 to that in 2000?
Provide a succinct answer. 0.62. What is the ratio of the Gross enrolment ratio (%) of Upper middle income in 1996 to that in 1997?
Your response must be concise. 0.96. What is the ratio of the Gross enrolment ratio (%) of France in 1996 to that in 1997?
Provide a succinct answer. 1.01. What is the ratio of the Gross enrolment ratio (%) of Morocco in 1996 to that in 1997?
Keep it short and to the point. 0.98. What is the ratio of the Gross enrolment ratio (%) of Nicaragua in 1996 to that in 1997?
Your answer should be compact. 0.88. What is the ratio of the Gross enrolment ratio (%) in Upper middle income in 1996 to that in 1998?
Offer a very short reply. 0.79. What is the ratio of the Gross enrolment ratio (%) of France in 1996 to that in 1998?
Your response must be concise. 1.03. What is the ratio of the Gross enrolment ratio (%) in Morocco in 1996 to that in 1998?
Offer a very short reply. 0.94. What is the ratio of the Gross enrolment ratio (%) of Nicaragua in 1996 to that in 1998?
Give a very brief answer. 0.83. What is the ratio of the Gross enrolment ratio (%) of Upper middle income in 1996 to that in 1999?
Provide a succinct answer. 0.75. What is the ratio of the Gross enrolment ratio (%) in France in 1996 to that in 1999?
Your answer should be very brief. 1.03. What is the ratio of the Gross enrolment ratio (%) of Nicaragua in 1996 to that in 1999?
Keep it short and to the point. 0.74. What is the ratio of the Gross enrolment ratio (%) of Upper middle income in 1996 to that in 2000?
Give a very brief answer. 0.7. What is the ratio of the Gross enrolment ratio (%) of France in 1996 to that in 2000?
Your response must be concise. 1.01. What is the ratio of the Gross enrolment ratio (%) in Nicaragua in 1996 to that in 2000?
Ensure brevity in your answer.  0.71. What is the ratio of the Gross enrolment ratio (%) in Upper middle income in 1997 to that in 1998?
Provide a succinct answer. 0.82. What is the ratio of the Gross enrolment ratio (%) of France in 1997 to that in 1998?
Your answer should be very brief. 1.01. What is the ratio of the Gross enrolment ratio (%) in Morocco in 1997 to that in 1998?
Provide a short and direct response. 0.96. What is the ratio of the Gross enrolment ratio (%) in Nicaragua in 1997 to that in 1998?
Your response must be concise. 0.93. What is the ratio of the Gross enrolment ratio (%) of Upper middle income in 1997 to that in 1999?
Offer a very short reply. 0.78. What is the ratio of the Gross enrolment ratio (%) of France in 1997 to that in 1999?
Your answer should be compact. 1.01. What is the ratio of the Gross enrolment ratio (%) in Morocco in 1997 to that in 1999?
Your answer should be compact. 1.03. What is the ratio of the Gross enrolment ratio (%) of Nicaragua in 1997 to that in 1999?
Your answer should be compact. 0.84. What is the ratio of the Gross enrolment ratio (%) of Upper middle income in 1997 to that in 2000?
Your answer should be very brief. 0.73. What is the ratio of the Gross enrolment ratio (%) in Morocco in 1997 to that in 2000?
Offer a very short reply. 1.03. What is the ratio of the Gross enrolment ratio (%) of Nicaragua in 1997 to that in 2000?
Offer a very short reply. 0.81. What is the ratio of the Gross enrolment ratio (%) of Upper middle income in 1998 to that in 1999?
Make the answer very short. 0.95. What is the ratio of the Gross enrolment ratio (%) of France in 1998 to that in 1999?
Offer a very short reply. 1. What is the ratio of the Gross enrolment ratio (%) in Morocco in 1998 to that in 1999?
Your response must be concise. 1.08. What is the ratio of the Gross enrolment ratio (%) in Nicaragua in 1998 to that in 1999?
Keep it short and to the point. 0.9. What is the ratio of the Gross enrolment ratio (%) of Upper middle income in 1998 to that in 2000?
Your response must be concise. 0.89. What is the ratio of the Gross enrolment ratio (%) of France in 1998 to that in 2000?
Provide a succinct answer. 0.99. What is the ratio of the Gross enrolment ratio (%) in Morocco in 1998 to that in 2000?
Your answer should be compact. 1.08. What is the ratio of the Gross enrolment ratio (%) of Nicaragua in 1998 to that in 2000?
Provide a short and direct response. 0.86. What is the ratio of the Gross enrolment ratio (%) of Upper middle income in 1999 to that in 2000?
Make the answer very short. 0.94. What is the ratio of the Gross enrolment ratio (%) of France in 1999 to that in 2000?
Make the answer very short. 0.99. What is the ratio of the Gross enrolment ratio (%) of Morocco in 1999 to that in 2000?
Provide a succinct answer. 1. What is the ratio of the Gross enrolment ratio (%) in Nicaragua in 1999 to that in 2000?
Provide a succinct answer. 0.96. What is the difference between the highest and the second highest Gross enrolment ratio (%) in Upper middle income?
Your answer should be compact. 2.58. What is the difference between the highest and the second highest Gross enrolment ratio (%) in France?
Your answer should be very brief. 0.54. What is the difference between the highest and the second highest Gross enrolment ratio (%) in Morocco?
Provide a succinct answer. 2.9. What is the difference between the highest and the second highest Gross enrolment ratio (%) in Nicaragua?
Give a very brief answer. 1.2. What is the difference between the highest and the lowest Gross enrolment ratio (%) in Upper middle income?
Provide a succinct answer. 13.65. What is the difference between the highest and the lowest Gross enrolment ratio (%) in France?
Provide a short and direct response. 3.33. What is the difference between the highest and the lowest Gross enrolment ratio (%) of Morocco?
Your answer should be compact. 6.26. What is the difference between the highest and the lowest Gross enrolment ratio (%) of Nicaragua?
Your response must be concise. 10.87. 